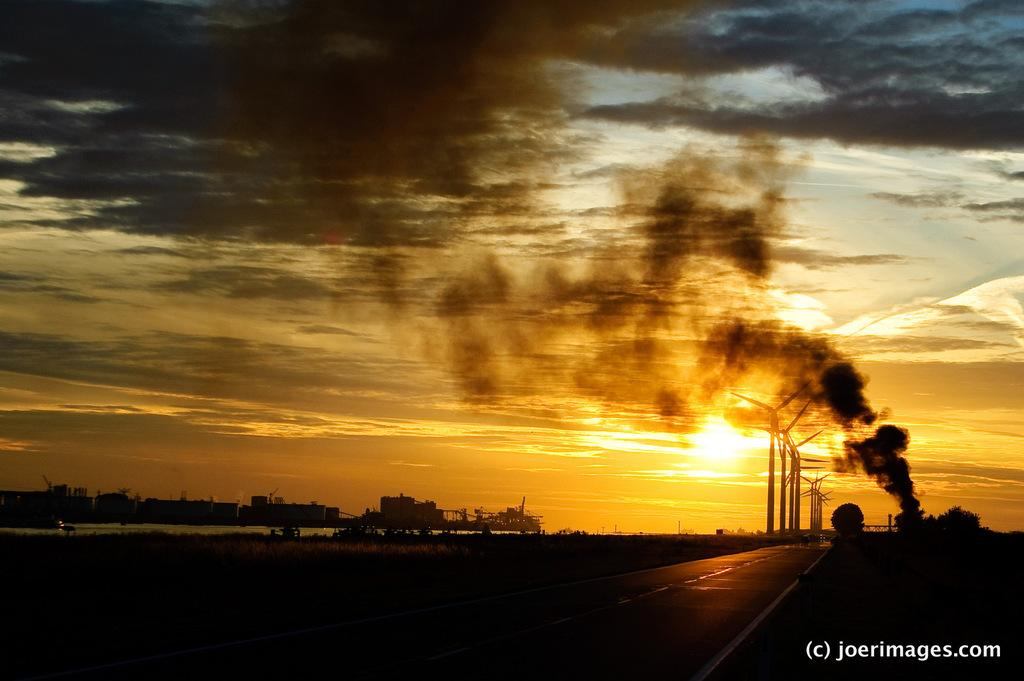What is located at the front of the image? There is a road in the front of the image. What can be seen in the background of the image? There are trees and buildings in the background of the image. What is the weather like in the image? The sky is cloudy, and the sun is visible, suggesting a partly cloudy day. Is there any indication of activity or movement in the image? Yes, there is smoke visible in the image, which may indicate some form of activity or movement. Can you see a snail carrying a suit on the road in the image? No, there is no snail or suit present in the image. What type of support is provided by the trees in the image? The trees in the image do not provide any visible support; they are simply part of the background. 